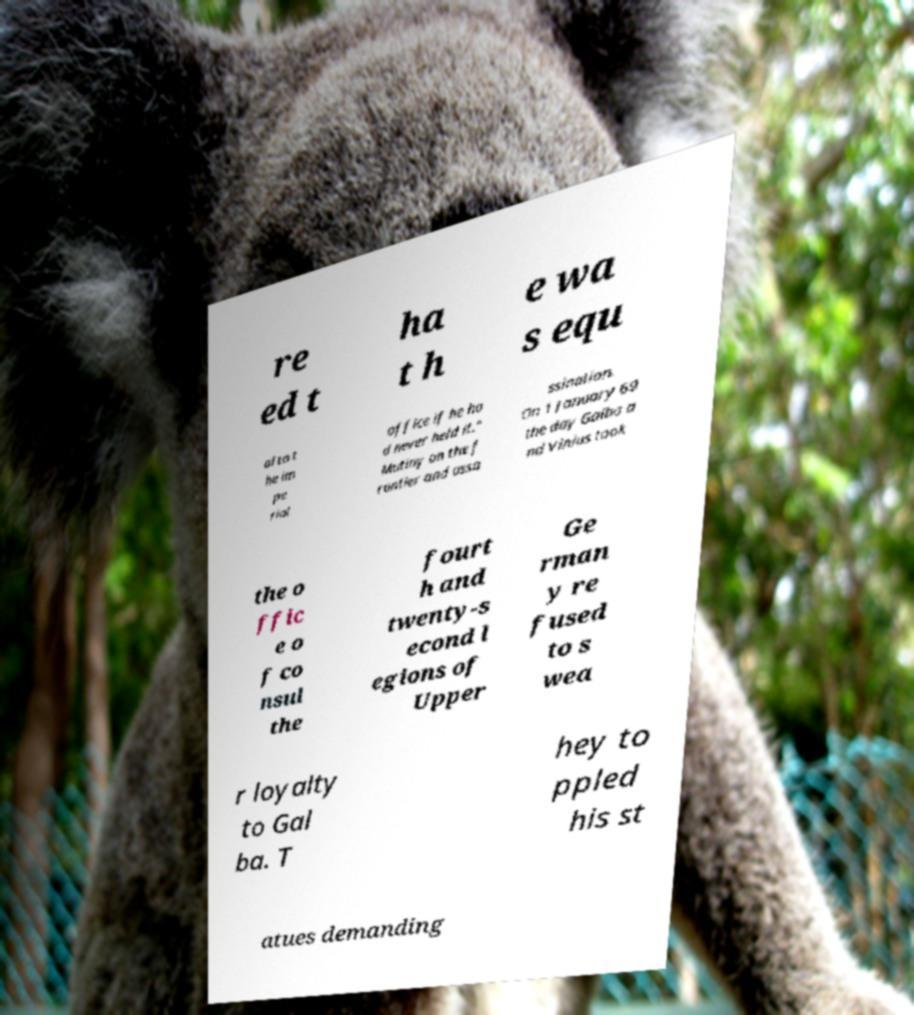What messages or text are displayed in this image? I need them in a readable, typed format. re ed t ha t h e wa s equ al to t he im pe rial office if he ha d never held it." Mutiny on the f rontier and assa ssination. On 1 January 69 the day Galba a nd Vinius took the o ffic e o f co nsul the fourt h and twenty-s econd l egions of Upper Ge rman y re fused to s wea r loyalty to Gal ba. T hey to ppled his st atues demanding 